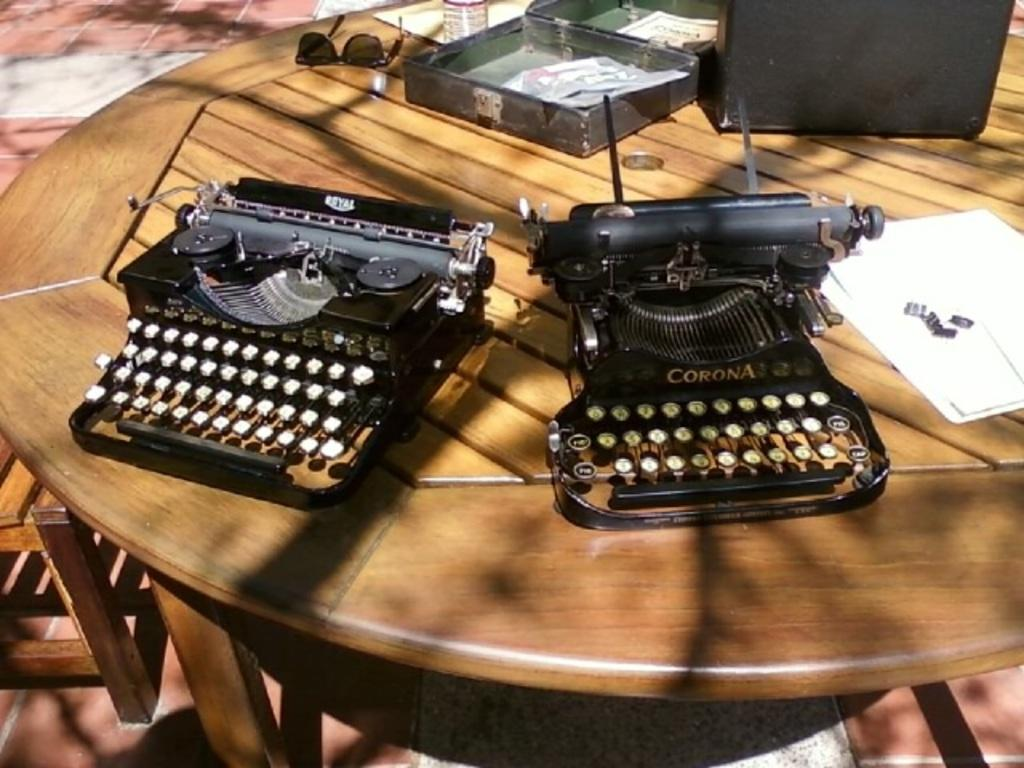<image>
Relay a brief, clear account of the picture shown. A Corona typewrite sits on a wooden table to the right of another typewriter. 